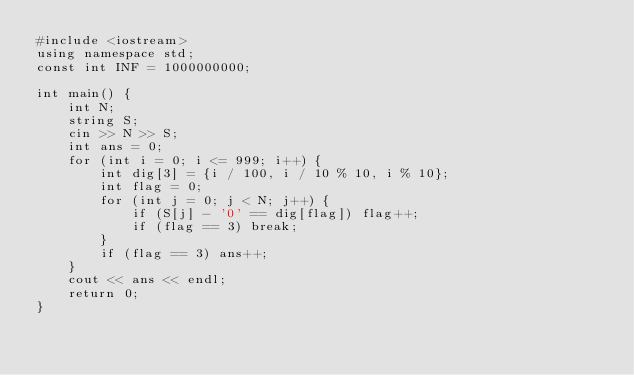Convert code to text. <code><loc_0><loc_0><loc_500><loc_500><_C++_>#include <iostream>
using namespace std;
const int INF = 1000000000;

int main() {
    int N; 
    string S;
    cin >> N >> S;
    int ans = 0;
    for (int i = 0; i <= 999; i++) {
        int dig[3] = {i / 100, i / 10 % 10, i % 10};
        int flag = 0;
        for (int j = 0; j < N; j++) {
            if (S[j] - '0' == dig[flag]) flag++;
            if (flag == 3) break;
        }
        if (flag == 3) ans++;
    }
    cout << ans << endl;
    return 0;
}</code> 